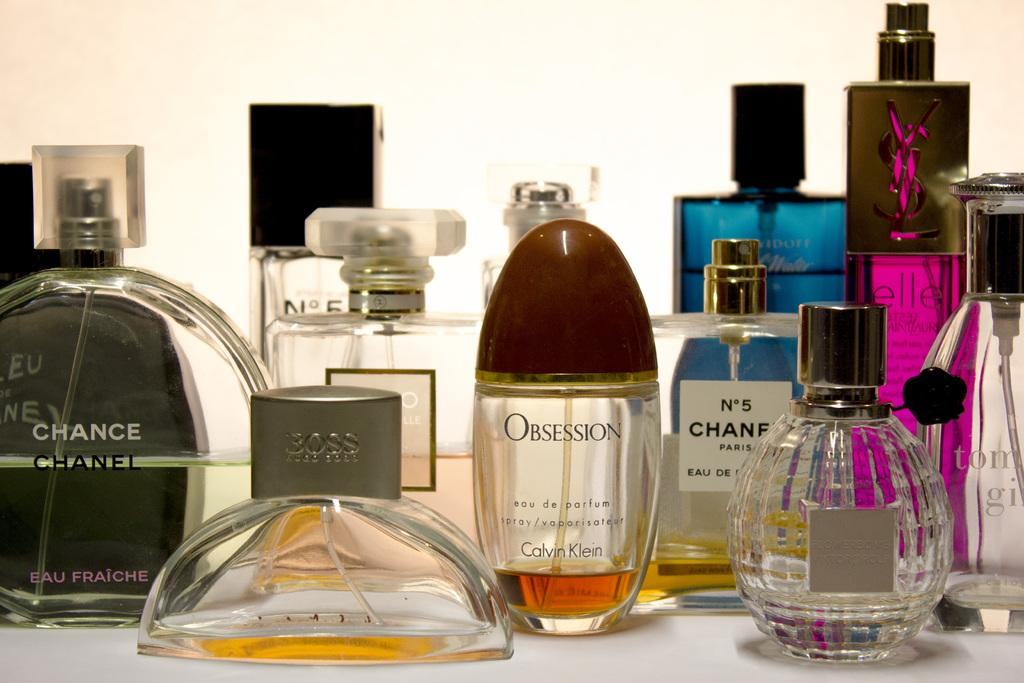<image>
Relay a brief, clear account of the picture shown. Several bottles of varying sizes and brands of perfume like chanel and obsession. 